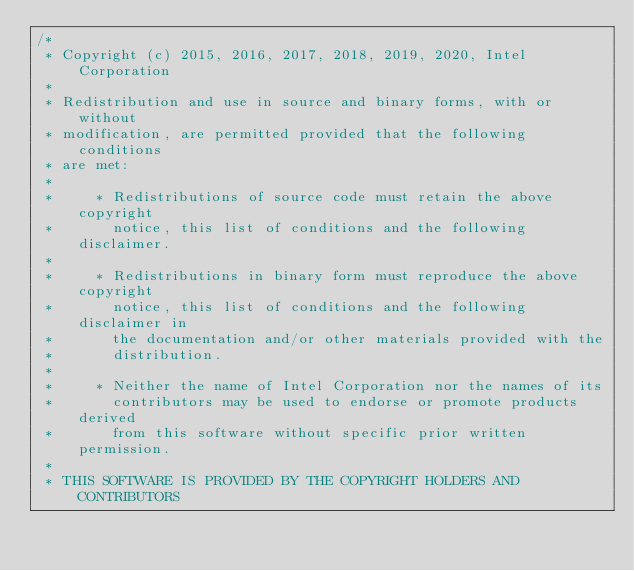<code> <loc_0><loc_0><loc_500><loc_500><_C_>/*
 * Copyright (c) 2015, 2016, 2017, 2018, 2019, 2020, Intel Corporation
 *
 * Redistribution and use in source and binary forms, with or without
 * modification, are permitted provided that the following conditions
 * are met:
 *
 *     * Redistributions of source code must retain the above copyright
 *       notice, this list of conditions and the following disclaimer.
 *
 *     * Redistributions in binary form must reproduce the above copyright
 *       notice, this list of conditions and the following disclaimer in
 *       the documentation and/or other materials provided with the
 *       distribution.
 *
 *     * Neither the name of Intel Corporation nor the names of its
 *       contributors may be used to endorse or promote products derived
 *       from this software without specific prior written permission.
 *
 * THIS SOFTWARE IS PROVIDED BY THE COPYRIGHT HOLDERS AND CONTRIBUTORS</code> 